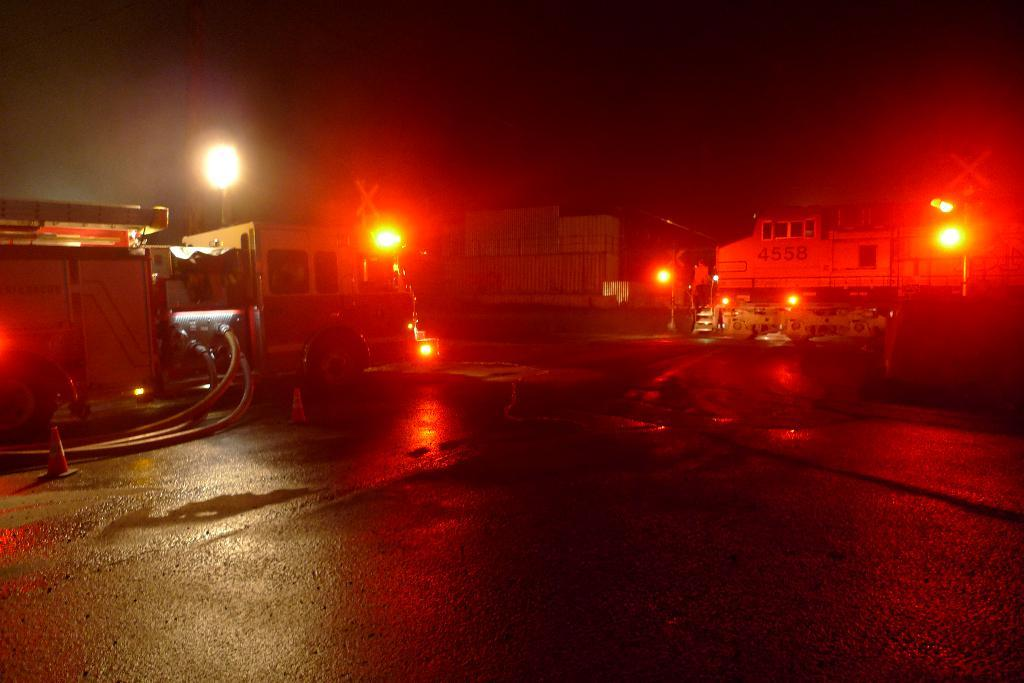What is on the road in the image? There is a vehicle on the road in the image. What else can be seen on the road besides the vehicle? Pipes and traffic poles are visible on the road. What can be seen on the backside of the image? There are lights, poles, and buildings visible on the backside of the image. What type of liquid is being transported by the vehicle in the image? There is no indication of the vehicle's contents or purpose in the image, so it cannot be determined what type of liquid, if any, is being transported. 